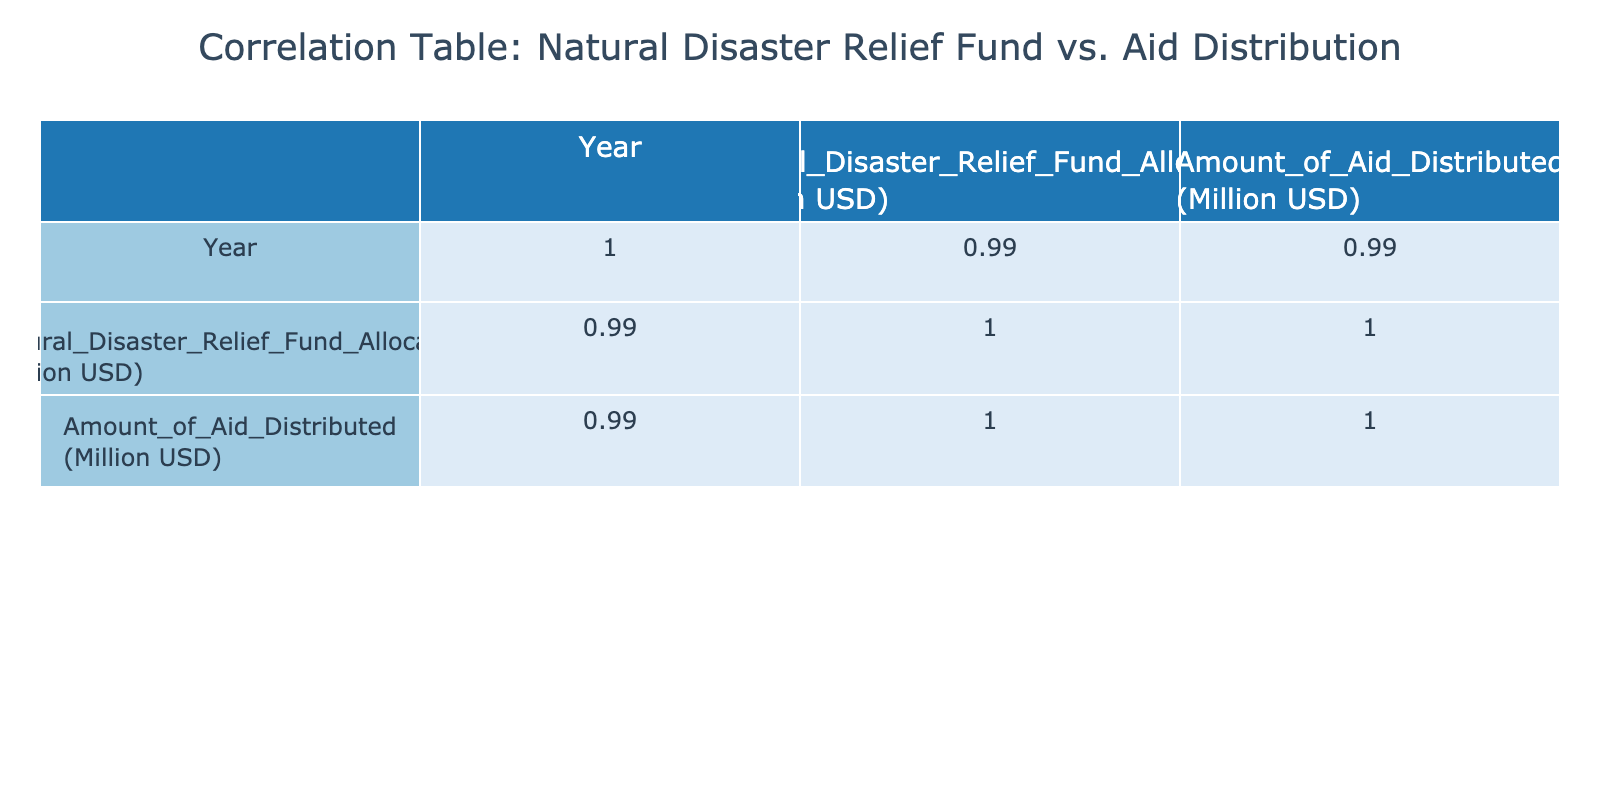What was the amount of aid distributed in 2020? The table provides the amount of aid distributed for each year, and for 2020, it shows 675 million USD.
Answer: 675 million USD What is the natural disaster relief fund allocation for the year 2022? The table indicates that in 2022, the natural disaster relief fund allocation was 900 million USD.
Answer: 900 million USD In which year was the highest amount of aid distributed? By examining the "Amount of Aid Distributed" column, we see that the maximum value is 900 million USD in 2023.
Answer: 2023 What is the average natural disaster relief fund allocation from 2018 to 2023? To find the average, sum the allocations (500 + 600 + 750 + 800 + 900 + 950 = 4000) and divide by the number of years (6), resulting in 4000/6 = 666.67 million USD.
Answer: 666.67 million USD Is the amount of aid distributed in 2021 greater than that in 2019? From the table, the aid distributed in 2021 is 720 million USD, while in 2019, it is 550 million USD. Since 720 million is greater than 550 million, the statement is true.
Answer: Yes Did the natural disaster relief fund allocation increase every year from 2018 to 2023? By checking the values in the "Natural Disaster Relief Fund Allocation" column, we observe it increased from 500 in 2018 to 950 in 2023 without any decreases in between. Thus, the answer is true.
Answer: Yes What was the total amount of aid distributed over the years? To calculate the total, add the aid distributed for each year (450 + 550 + 675 + 720 + 850 + 900 = 4145 million USD).
Answer: 4145 million USD In 2021, what was the difference between the natural disaster relief fund allocation and the amount of aid distributed? The allocation in 2021 is 800 million USD and the aid distributed is 720 million USD. The difference is 800 - 720 = 80 million USD.
Answer: 80 million USD What was the correlation coefficient between fund allocation and aid distributed? The correlation values can be observed in the table. For "Natural Disaster Relief Fund Allocation" and "Amount of Aid Distributed," the correlation coefficient is 0.98, indicating a strong positive correlation.
Answer: 0.98 